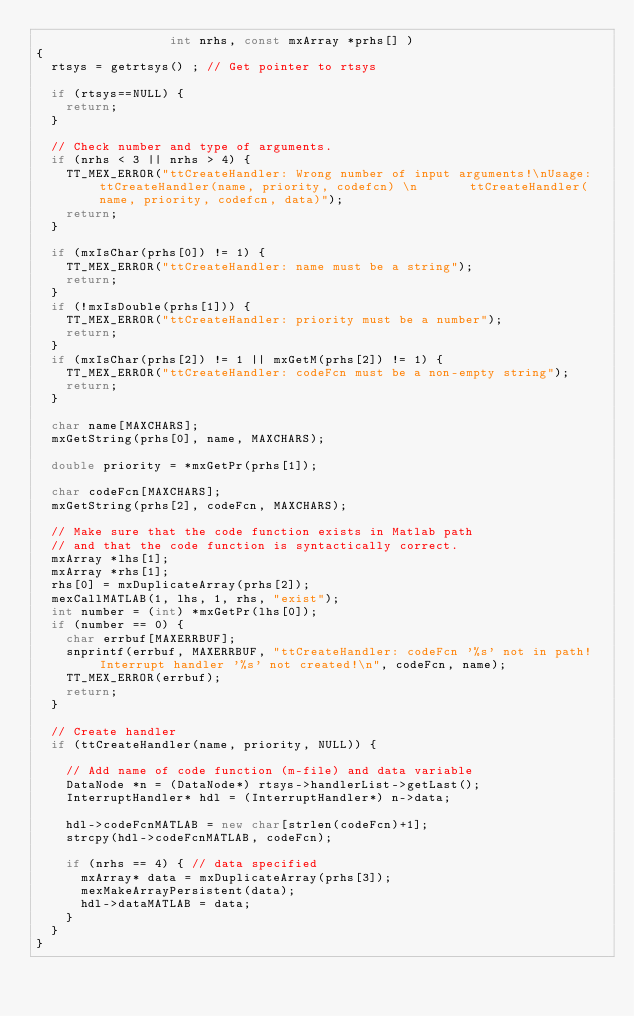<code> <loc_0><loc_0><loc_500><loc_500><_C++_>                  int nrhs, const mxArray *prhs[] )
{
  rtsys = getrtsys() ; // Get pointer to rtsys 

  if (rtsys==NULL) {
    return;
  }

  // Check number and type of arguments. 
  if (nrhs < 3 || nrhs > 4) {
    TT_MEX_ERROR("ttCreateHandler: Wrong number of input arguments!\nUsage: ttCreateHandler(name, priority, codefcn) \n       ttCreateHandler(name, priority, codefcn, data)");
    return;
  }

  if (mxIsChar(prhs[0]) != 1) {
    TT_MEX_ERROR("ttCreateHandler: name must be a string");
    return;
  }
  if (!mxIsDouble(prhs[1])) {
    TT_MEX_ERROR("ttCreateHandler: priority must be a number");
    return;
  }
  if (mxIsChar(prhs[2]) != 1 || mxGetM(prhs[2]) != 1) {
    TT_MEX_ERROR("ttCreateHandler: codeFcn must be a non-empty string");
    return;
  }
  
  char name[MAXCHARS];
  mxGetString(prhs[0], name, MAXCHARS);
  
  double priority = *mxGetPr(prhs[1]);

  char codeFcn[MAXCHARS];
  mxGetString(prhs[2], codeFcn, MAXCHARS);

  // Make sure that the code function exists in Matlab path
  // and that the code function is syntactically correct.
  mxArray *lhs[1];
  mxArray *rhs[1];
  rhs[0] = mxDuplicateArray(prhs[2]);
  mexCallMATLAB(1, lhs, 1, rhs, "exist");
  int number = (int) *mxGetPr(lhs[0]);
  if (number == 0) {
    char errbuf[MAXERRBUF];
    snprintf(errbuf, MAXERRBUF, "ttCreateHandler: codeFcn '%s' not in path! Interrupt handler '%s' not created!\n", codeFcn, name);
    TT_MEX_ERROR(errbuf);
    return;
  }

  // Create handler
  if (ttCreateHandler(name, priority, NULL)) {

    // Add name of code function (m-file) and data variable
    DataNode *n = (DataNode*) rtsys->handlerList->getLast();
    InterruptHandler* hdl = (InterruptHandler*) n->data;

    hdl->codeFcnMATLAB = new char[strlen(codeFcn)+1];
    strcpy(hdl->codeFcnMATLAB, codeFcn);
     
    if (nrhs == 4) { // data specified
      mxArray* data = mxDuplicateArray(prhs[3]);
      mexMakeArrayPersistent(data);
      hdl->dataMATLAB = data;
    }
  }
}
</code> 